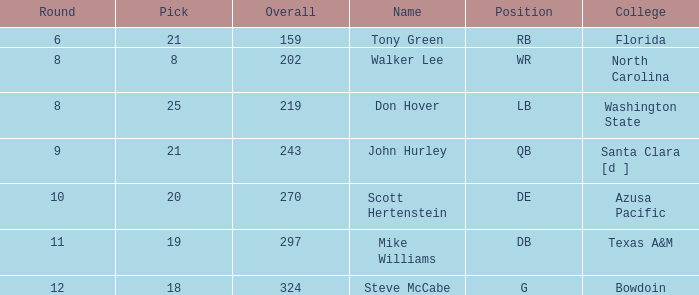Which college has a pick less than 25, an overall greater than 159, a round less than 10, and wr as the position? North Carolina. 